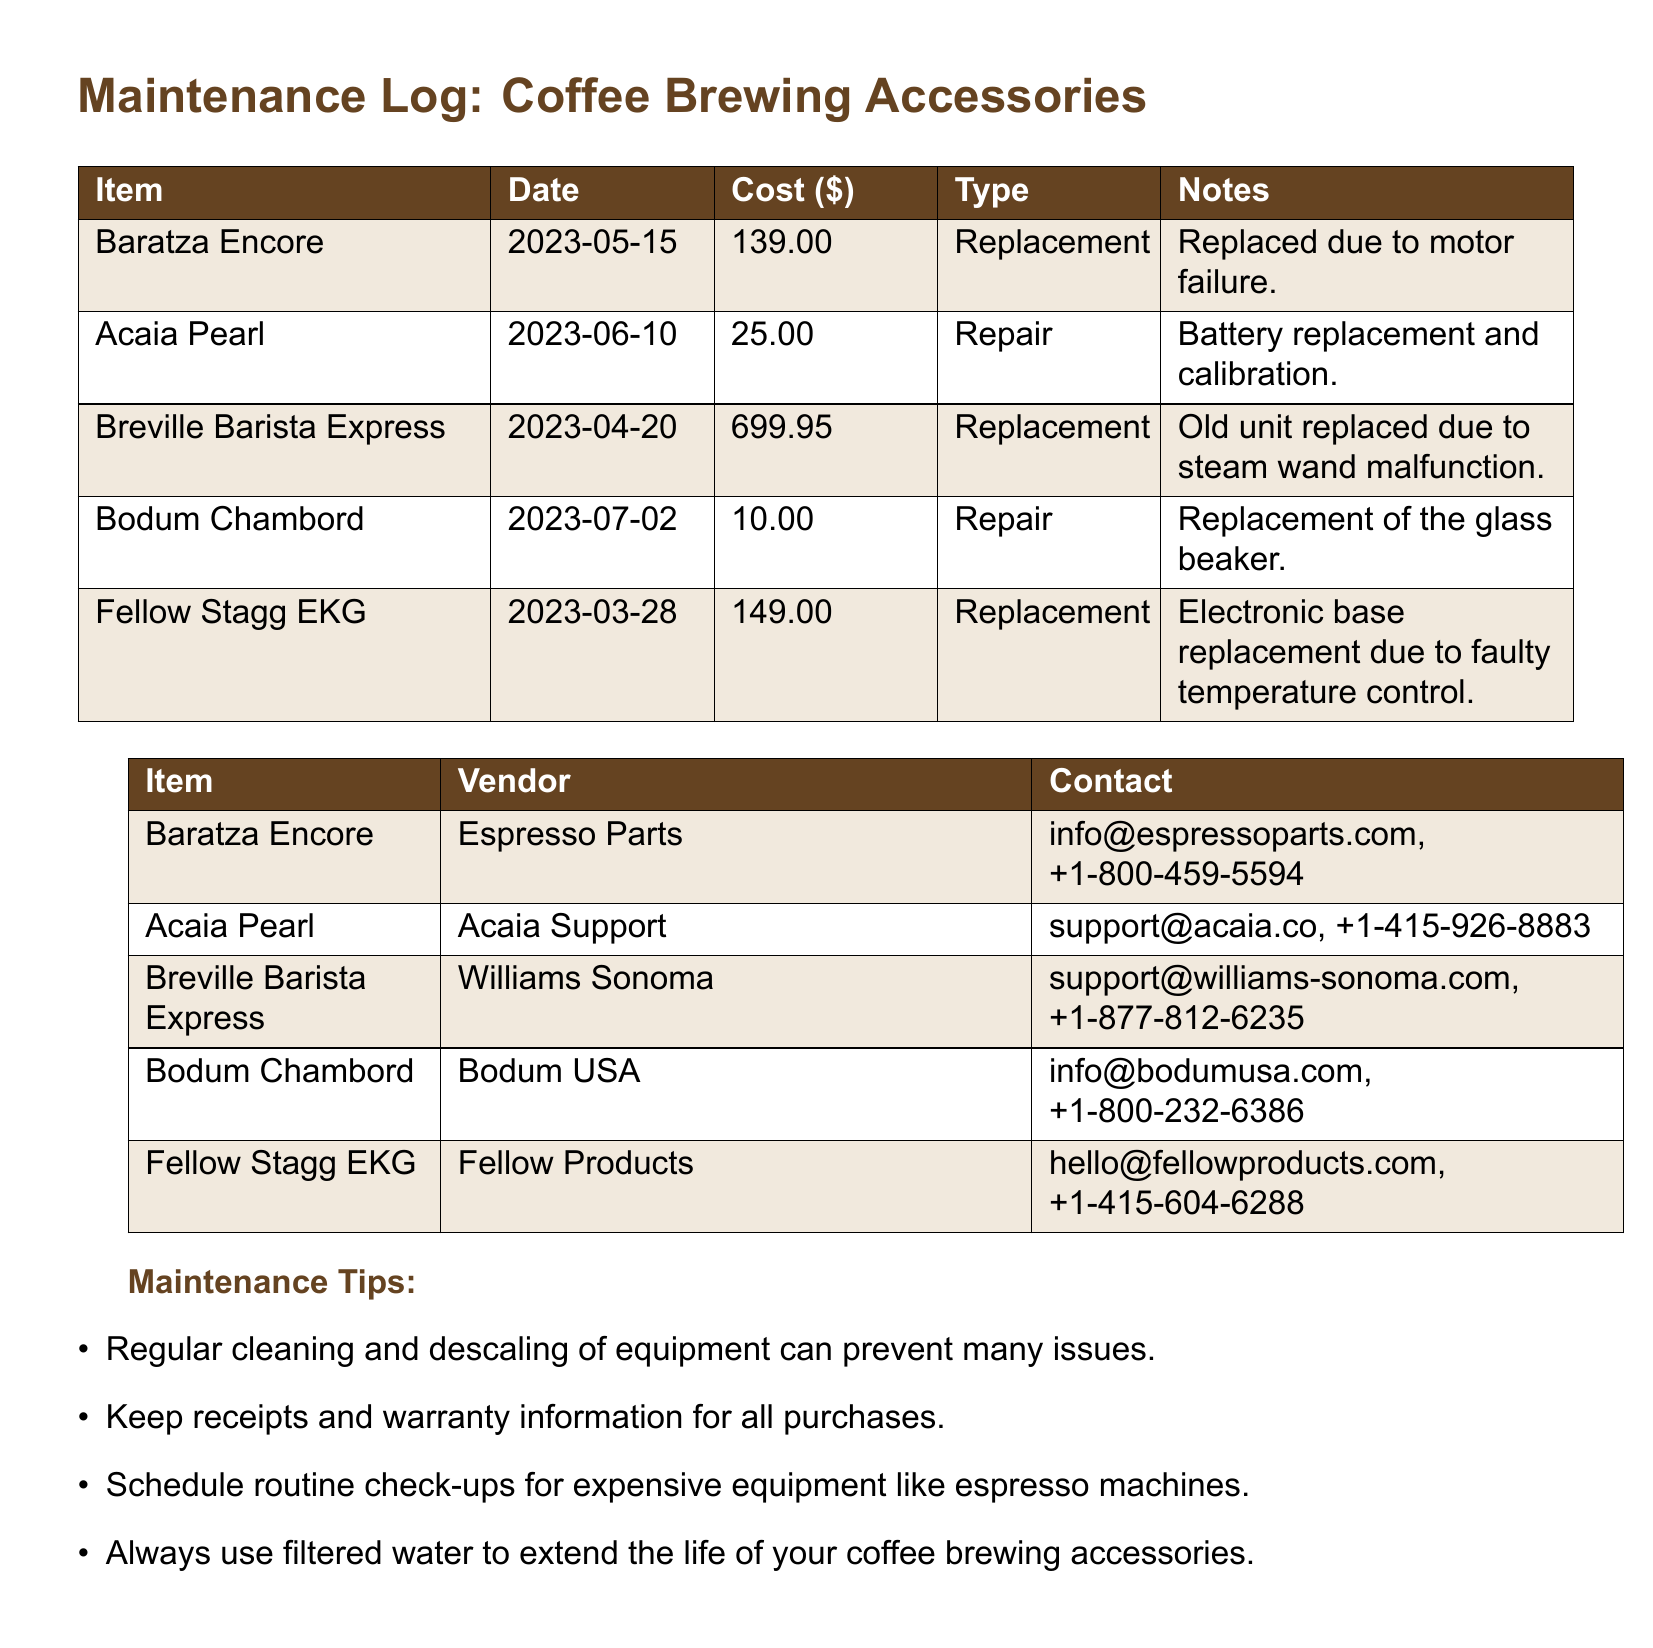What item was replaced due to motor failure? The document lists the Baratza Encore as replaced due to motor failure.
Answer: Baratza Encore What was the cost of the battery replacement for the Acaia Pearl? The document states the cost for the Acaia Pearl repair (battery replacement and calibration) is $25.00.
Answer: $25.00 When was the Breville Barista Express replaced? The replacement date for the Breville Barista Express is noted as 2023-04-20.
Answer: 2023-04-20 Which vendor is associated with the Bodum Chambord? The vendor for the Bodum Chambord is listed as Bodum USA.
Answer: Bodum USA What maintenance tip is provided in the document? The document includes regular cleaning and descaling of equipment as one of the maintenance tips.
Answer: Regular cleaning and descaling What type of repair was conducted on the Fellow Stagg EKG? The Fellow Stagg EKG was replaced due to a faulty electronic base.
Answer: Replacement Which item had the highest replacement cost? The Breville Barista Express has the highest replacement cost at $699.95.
Answer: $699.95 How many items were replaced or repaired according to the log? The document lists a total of five items under repairs and replacements.
Answer: Five What is the contact information for Espresso Parts? The contact information for Espresso Parts is provided as info@espressoparts.com, +1-800-459-5594.
Answer: info@espressoparts.com, +1-800-459-5594 